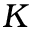<formula> <loc_0><loc_0><loc_500><loc_500>K</formula> 